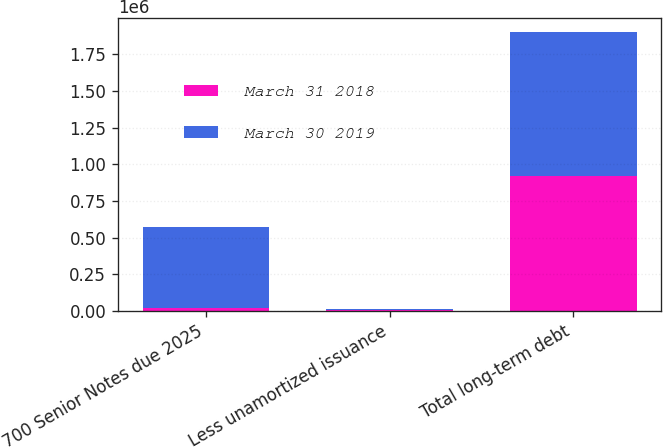Convert chart to OTSL. <chart><loc_0><loc_0><loc_500><loc_500><stacked_bar_chart><ecel><fcel>700 Senior Notes due 2025<fcel>Less unamortized issuance<fcel>Total long-term debt<nl><fcel>March 31 2018<fcel>23404<fcel>4134<fcel>919270<nl><fcel>March 30 2019<fcel>548500<fcel>9674<fcel>983290<nl></chart> 